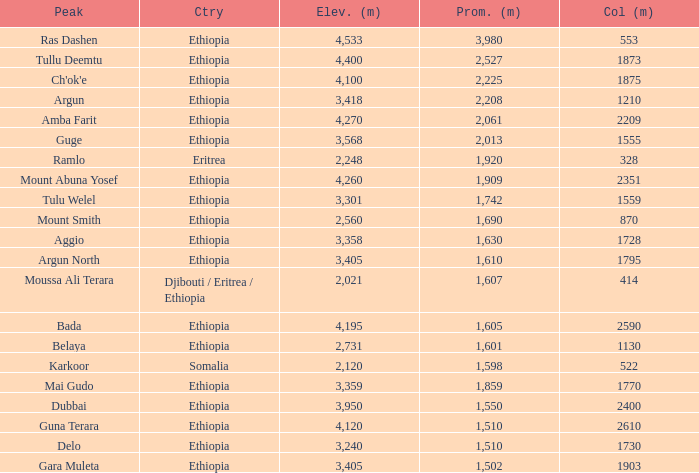What is the sum of the prominence in m of moussa ali terara peak? 1607.0. 